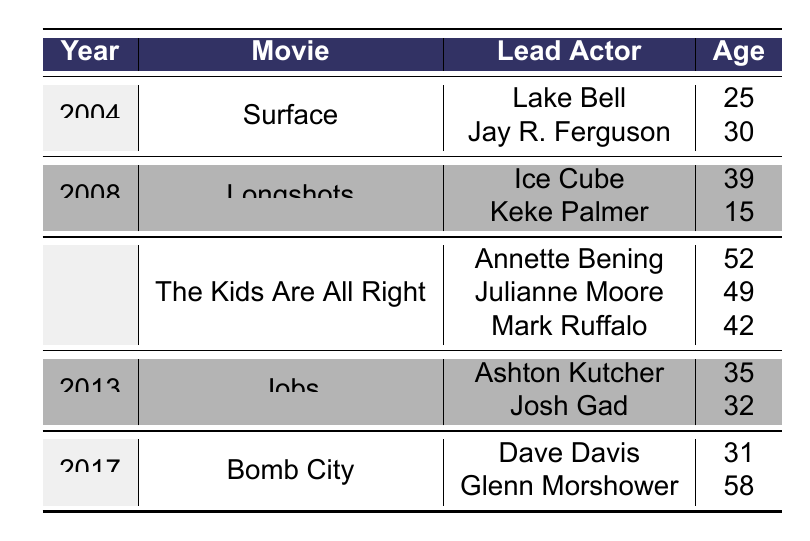What is the average age of lead actors in the movie "The Kids Are All Right"? The lead actors in "The Kids Are All Right" are Annette Bening (52), Julianne Moore (49), and Mark Ruffalo (42). To find the average age, we sum their ages: 52 + 49 + 42 = 143. There are 3 actors, so we divide 143 by 3, which equals approximately 47.67.
Answer: 47.67 Which lead actor was the youngest in the dataset? If we look through the ages of all lead actors, Keke Palmer is 15, Lake Bell is 25, Jay R. Ferguson is 30, Ice Cube is 39, Annette Bening is 52, Julianne Moore is 49, Mark Ruffalo is 42, Ashton Kutcher is 35, Josh Gad is 32, Dave Davis is 31, and Glenn Morshower is 58. Keke Palmer is the youngest at 15 years old.
Answer: Keke Palmer In how many movies did Eddie Hassell have lead actors aged 30 or younger? We check each movie in the table. In "Surface," both lead actors are above 30. In "Longshots," Keke Palmer is 15. In "The Kids Are All Right," all actors are above 30. In "Jobs," both actors are above 30. In "Bomb City," all actors are above 30. Only "Longshots" has a lead actor aged 30 or younger. Thus, there is 1 movie.
Answer: 1 What is the difference in age between the oldest and youngest lead actors across all movies? The oldest lead actor is Glenn Morshower at 58, and the youngest lead actor is Keke Palmer at 15. To find the difference, we subtract the youngest age from the oldest: 58 - 15 = 43.
Answer: 43 Are there any movies where the lead actors are both above 40 years old? We look at "The Kids Are All Right," where the ages are 52, 49, and 42. All are above 40. In "Bomb City," Dave Davis is 31, and Glenn Morshower is 58; only one actor is below 40. The other movies have at least one actor below 40. Therefore, the only movie where both lead actors are above 40 is "The Kids Are All Right."
Answer: Yes How many different years are represented in the table? The movies listed are from the years 2004, 2008, 2010, 2013, and 2017. Counting these gives us a total of 5 different years represented in the table.
Answer: 5 Which movie had the highest average age of lead actors? Calculate the average for each movie: "Surface": (25 + 30) / 2 = 27.5, "Longshots": (39 + 15) / 2 = 27, "The Kids Are All Right": (52 + 49 + 42) / 3 = 47.67, "Jobs": (35 + 32) / 2 = 33.5, "Bomb City": (31 + 58) / 2 = 44.5. The highest average is from "The Kids Are All Right" at 47.67.
Answer: The Kids Are All Right What was the age of the lead actor in "Jobs"? In "Jobs," the lead actors are Ashton Kutcher, who is 35, and Josh Gad, who is 32. Therefore, the ages of lead actors in that movie are 35 and 32.
Answer: 35 and 32 How many lead actors are above the age of 40 years old? We review the ages: Lake Bell (25), Jay R. Ferguson (30), Ice Cube (39), Keke Palmer (15), Annette Bening (52), Julianne Moore (49), Mark Ruffalo (42), Ashton Kutcher (35), Josh Gad (32), Dave Davis (31), and Glenn Morshower (58). The actors above 40 are Annette Bening (52), Julianne Moore (49), Mark Ruffalo (42), and Glenn Morshower (58). This totals to 4 lead actors above 40.
Answer: 4 What was the average age of lead actors for movies released in odd years? The odd years in the dataset are 2005 (not present), 2008 (Longshots), 2010 (The Kids Are All Right), 2011 (not present), and 2013 (Jobs). For "Longshots," the average age is (39 + 15) / 2 = 27. For "Jobs," the average age is (35 + 32) / 2 = 33.5. Total average of ages from these two movies is (27 + 33.5) / 2 = 30.75. Thus, the average age for lead actors in odd years is 30.75.
Answer: 30.75 